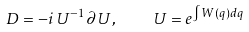Convert formula to latex. <formula><loc_0><loc_0><loc_500><loc_500>D = - i \, U ^ { - 1 } \partial \, U , \quad U = e ^ { \int W ( q ) d q }</formula> 